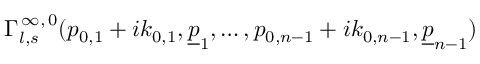<formula> <loc_0><loc_0><loc_500><loc_500>\Gamma _ { l , s } ^ { \, \infty , \, 0 } ( p _ { 0 , 1 } + i k _ { 0 , 1 } , \underline { p } _ { 1 } , \dots , p _ { 0 , n - 1 } + i k _ { 0 , n - 1 } , \underline { p } _ { n - 1 } )</formula> 